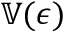Convert formula to latex. <formula><loc_0><loc_0><loc_500><loc_500>\mathbb { V } ( \boldsymbol \epsilon )</formula> 